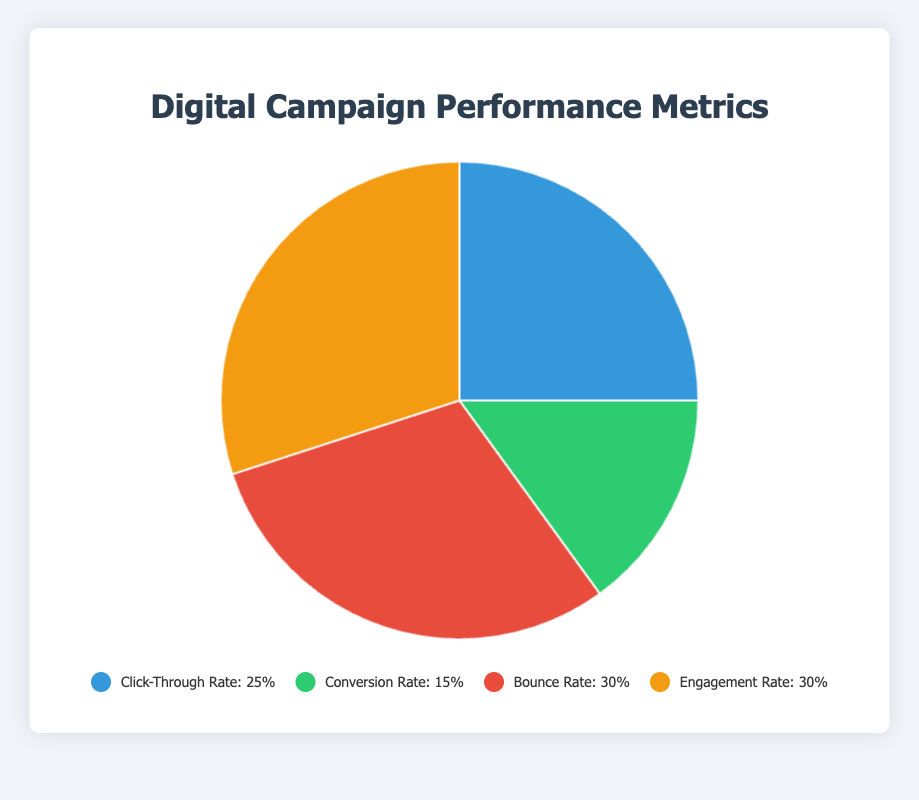What is the most common user interaction rate according to the pie chart? To find the most common user interaction rate, identify the metric with the largest percentage in the pie chart. The Bounce Rate and Engagement Rate each hold 30% of the chart, making them the most common user interaction rates.
Answer: Bounce Rate and Engagement Rate (30%) What is the combined percentage of the Click-Through Rate and Conversion Rate? To find the combined percentage, add the Click-Through Rate (25%) and the Conversion Rate (15%). Thus, 25% + 15% = 40%.
Answer: 40% Which rate is higher, the Click-Through Rate or the Conversion Rate, and by how much? To determine which rate is higher, compare the Click-Through Rate (25%) with the Conversion Rate (15%). The difference is 25% - 15% = 10%.
Answer: Click-Through Rate is higher by 10% What percentage of users either bounce or engage with the content? Add the Bounce Rate (30%) and the Engagement Rate (30%) to determine the total percentage of users who either bounce or engage. 30% + 30% = 60%.
Answer: 60% Which metric does the color blue represent in the pie chart? Identify the color blue in the legend or the chart, which corresponds to the Click-Through Rate with a percentage of 25%.
Answer: Click-Through Rate How does the Bounce Rate compare to the Click-Through Rate in terms of percentage difference? Calculate the percentage difference between the Bounce Rate (30%) and the Click-Through Rate (25%). The difference is 30% - 25% = 5%.
Answer: 5% What would be the average percentage if we averaged all four metrics? To find the average percentage, sum all the percentages of the four metrics and divide by the number of metrics. (25% + 15% + 30% + 30%) / 4. This equals 100% / 4 = 25%.
Answer: 25% If only the Click-Through Rate and Engagement Rate were considered, what would their combined percentage be? Add the Click-Through Rate (25%) and the Engagement Rate (30%) to find their combined percentage. 25% + 30% = 55%.
Answer: 55% 